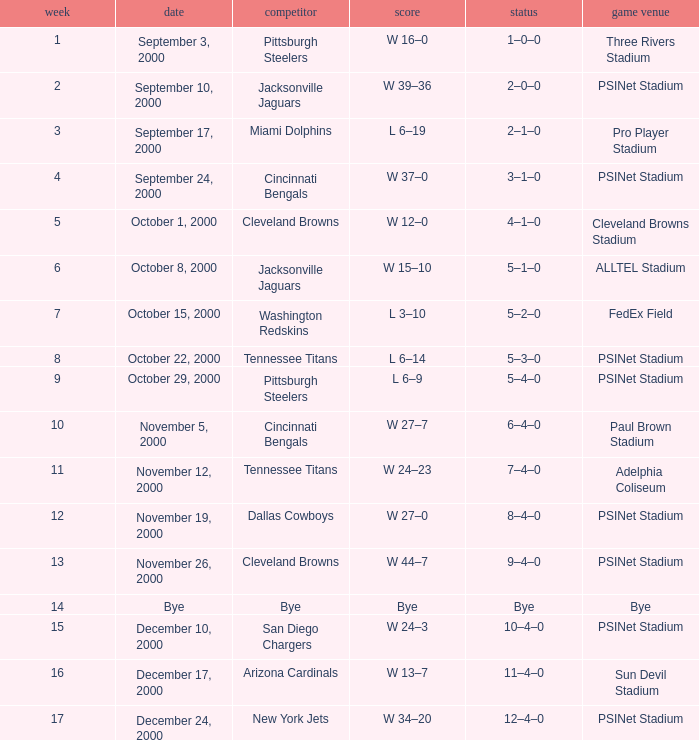What's the record after week 16? 12–4–0. 